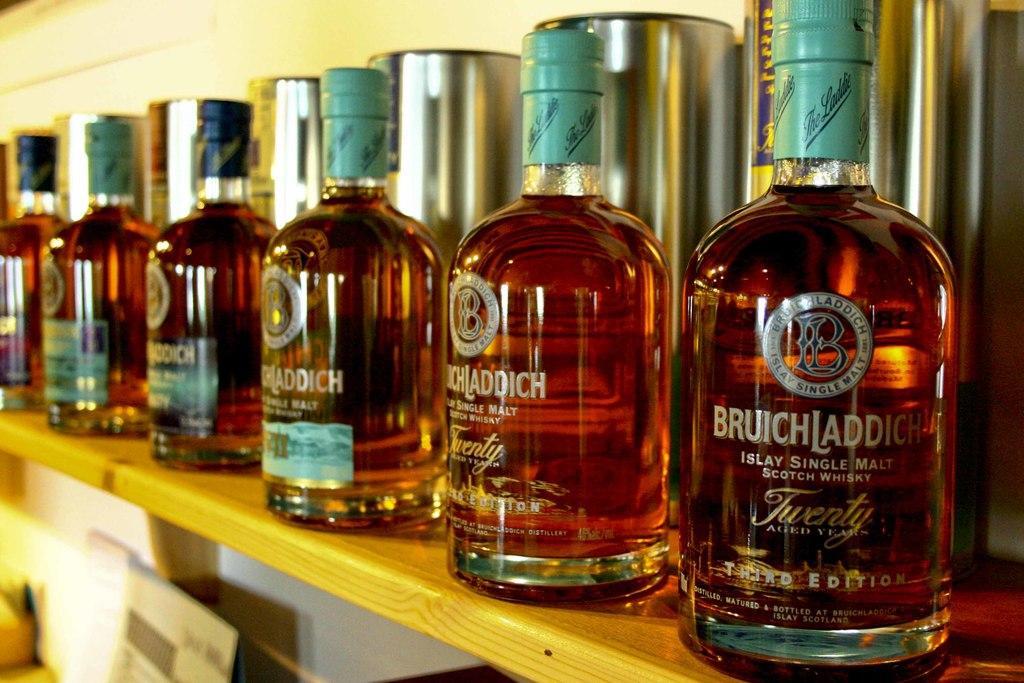In one or two sentences, can you explain what this image depicts? In the image there are total five whisky bottles kept on a shelf, in the background there is a wall. 